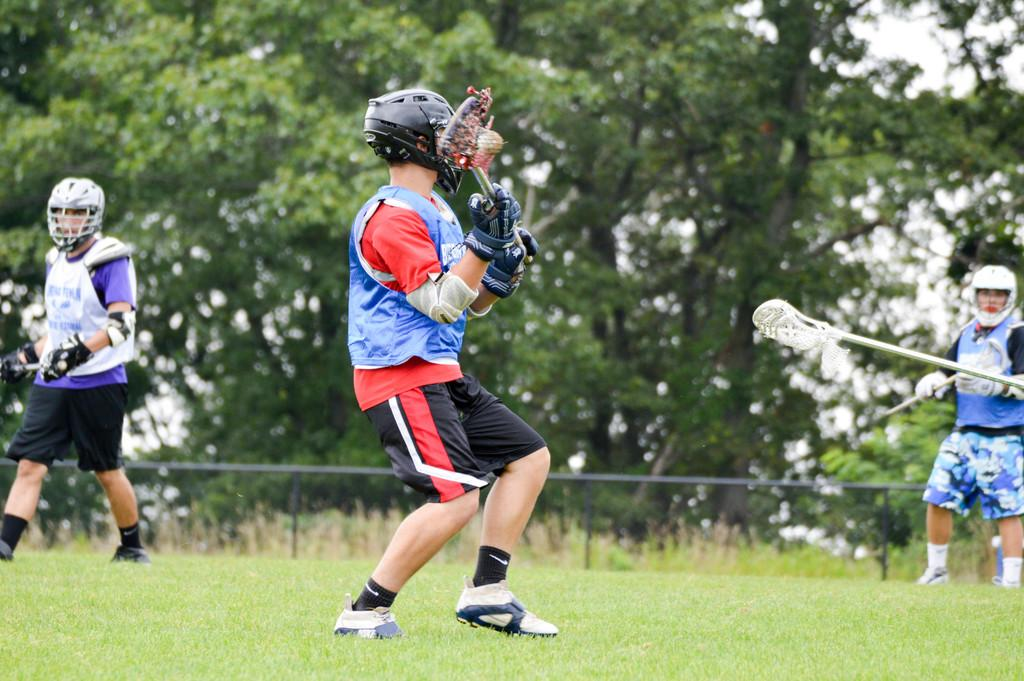What can be seen in the background of the image? In the background of the image, there are trees, railing, plants, and green grass. What are the people in the image wearing on their heads? The people in the image are wearing helmets. What are the people holding in their hands? The people are holding sticks in their hands. What type of gloves are the people wearing? The people are wearing gloves. What news headline is visible on the sign in the image? There is no sign or news headline present in the image. What word is written on the bear's shirt in the image? There is no bear or shirt present in the image. 